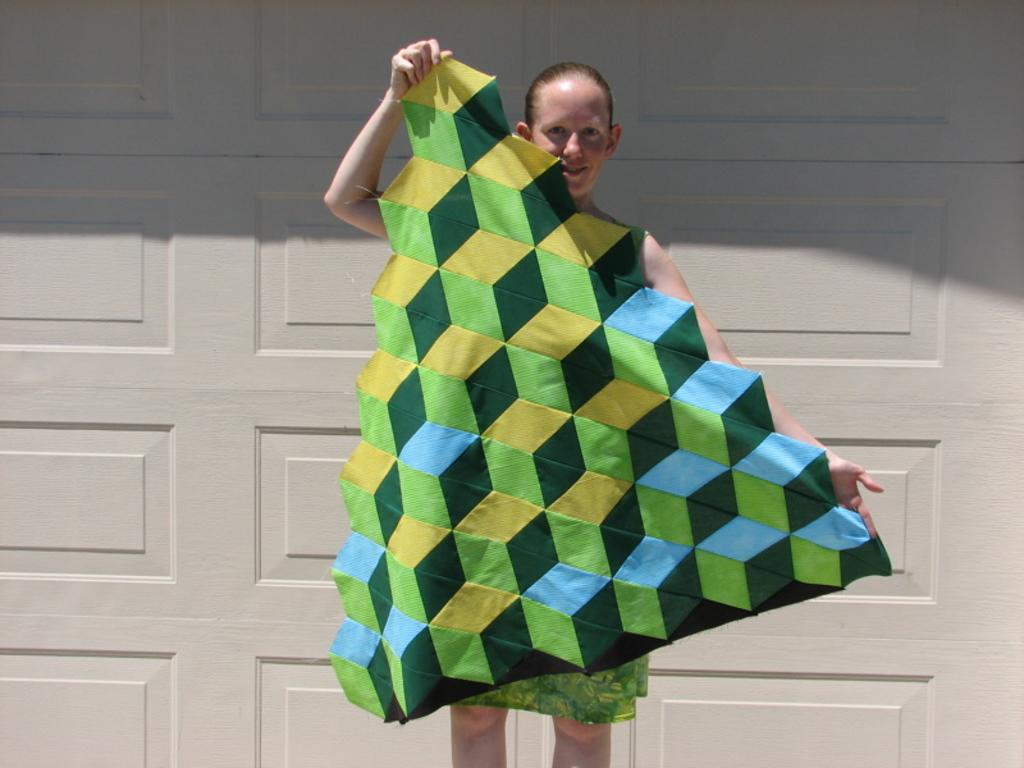Who is the main subject in the image? There is a woman in the image. What is the woman holding in her hands? The woman is holding a cloth in her hands. What can be seen in the background of the image? There is a white color wall in the background of the image. What type of crow is sitting on the woman's shoulder in the image? There is no crow present in the image; the woman is holding a cloth in her hands. What word is written on the cloth that the woman is holding? There is no word visible on the cloth in the image. 